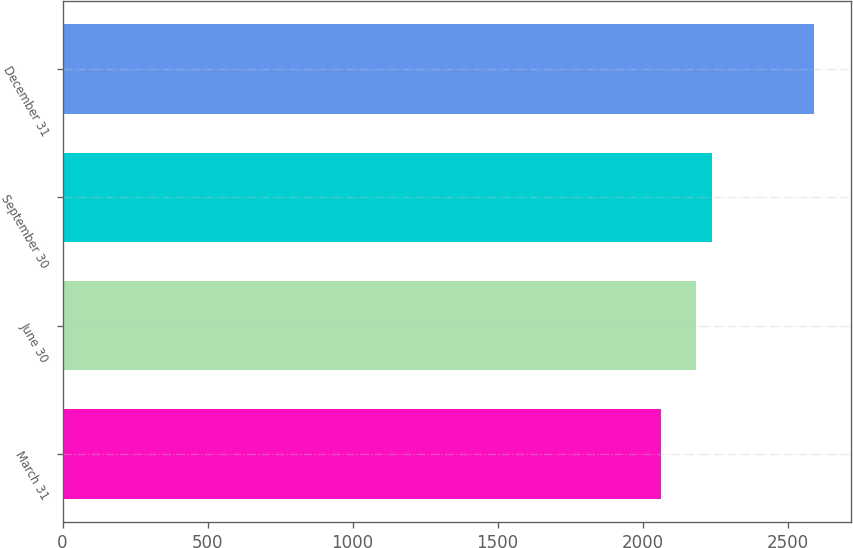Convert chart. <chart><loc_0><loc_0><loc_500><loc_500><bar_chart><fcel>March 31<fcel>June 30<fcel>September 30<fcel>December 31<nl><fcel>2063.8<fcel>2185.8<fcel>2238.4<fcel>2589.8<nl></chart> 